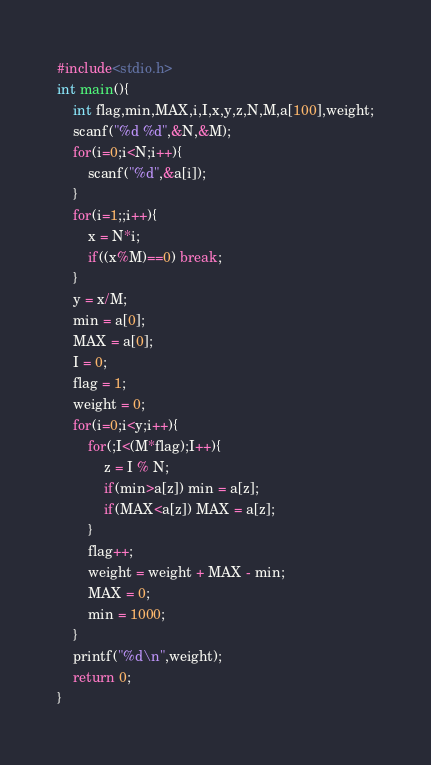<code> <loc_0><loc_0><loc_500><loc_500><_C_>#include<stdio.h>
int main(){
	int flag,min,MAX,i,I,x,y,z,N,M,a[100],weight;
	scanf("%d %d",&N,&M);
	for(i=0;i<N;i++){
		scanf("%d",&a[i]);
	}
	for(i=1;;i++){
		x = N*i;
		if((x%M)==0) break;
	}
	y = x/M;
	min = a[0];
	MAX = a[0];
	I = 0;
	flag = 1;
	weight = 0;
	for(i=0;i<y;i++){
		for(;I<(M*flag);I++){
			z = I % N;
			if(min>a[z]) min = a[z];
			if(MAX<a[z]) MAX = a[z];
		}
		flag++;
		weight = weight + MAX - min;
		MAX = 0;
		min = 1000;
	}
	printf("%d\n",weight);
	return 0;
}</code> 